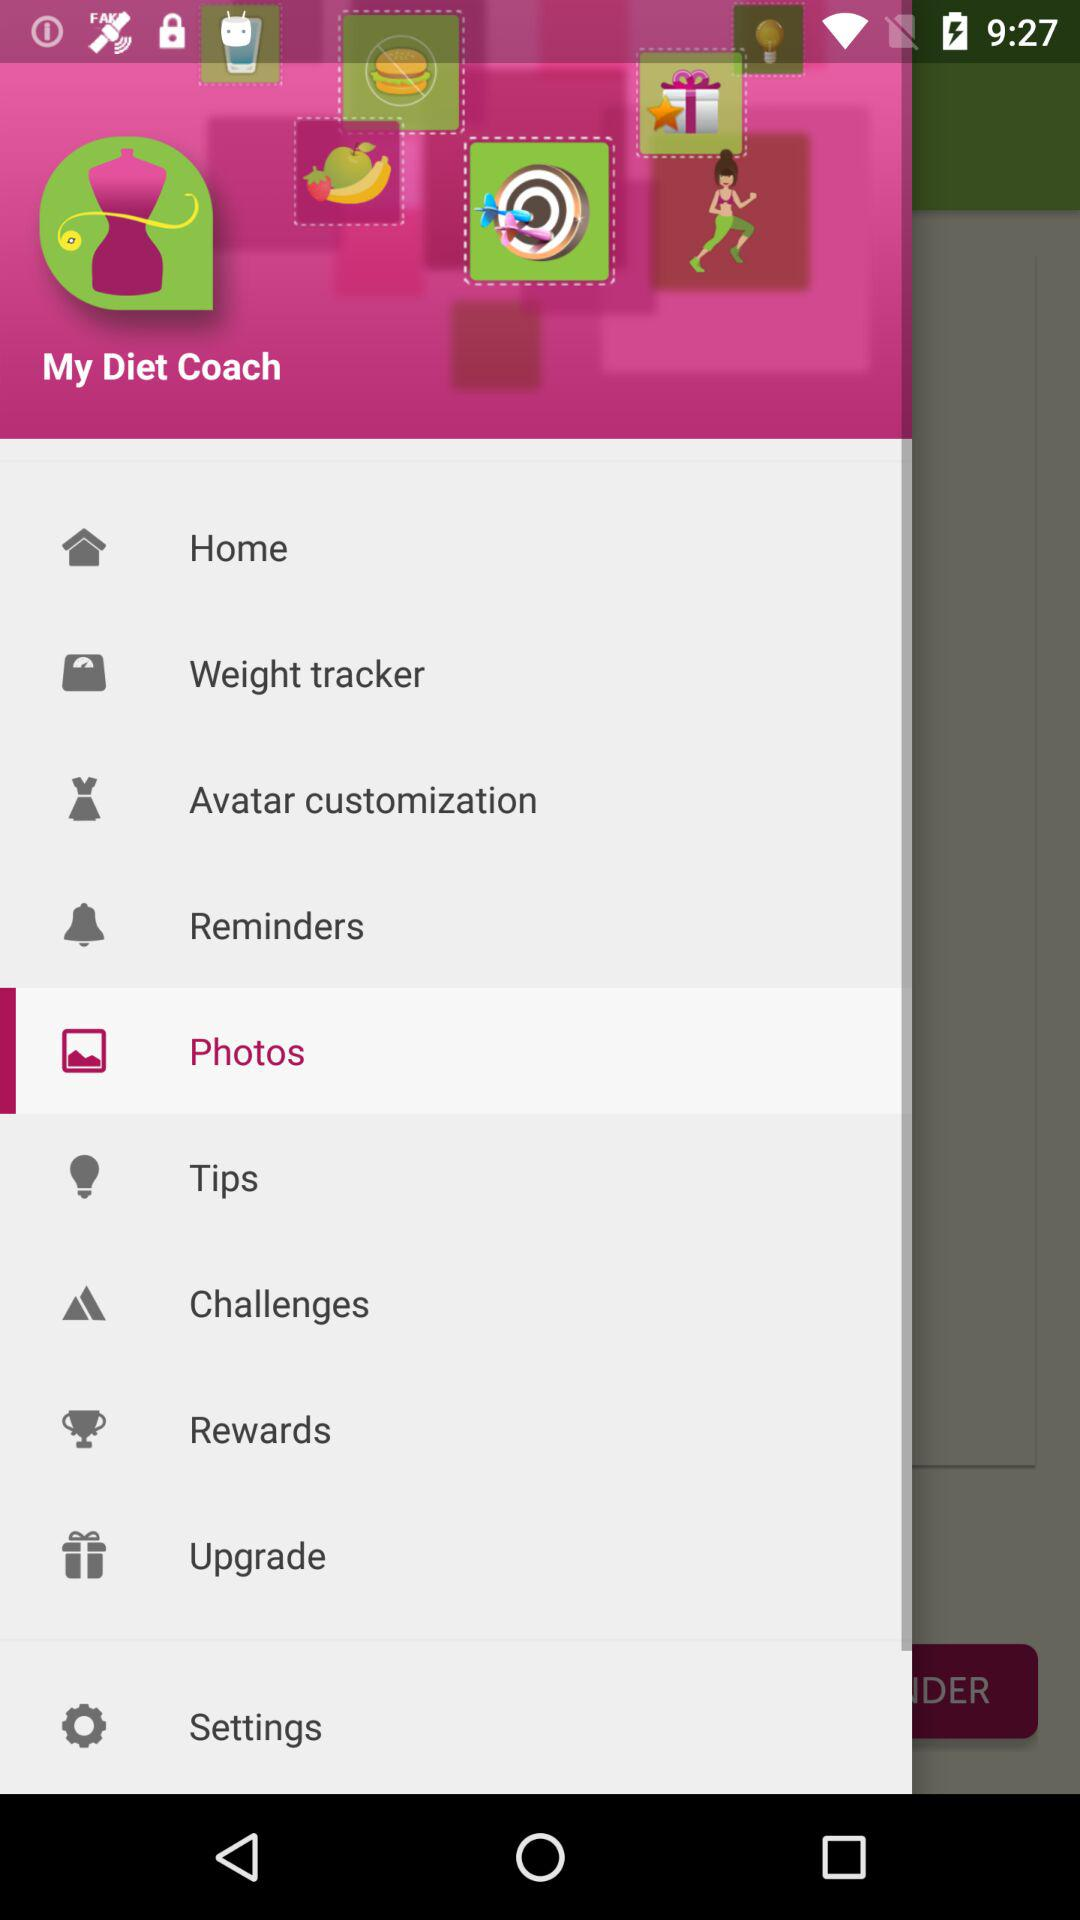What is the name of the application? The application name is "My Diet Coach". 